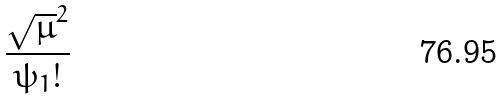<formula> <loc_0><loc_0><loc_500><loc_500>\frac { \sqrt { \mu } ^ { 2 } } { \psi _ { 1 } ! }</formula> 